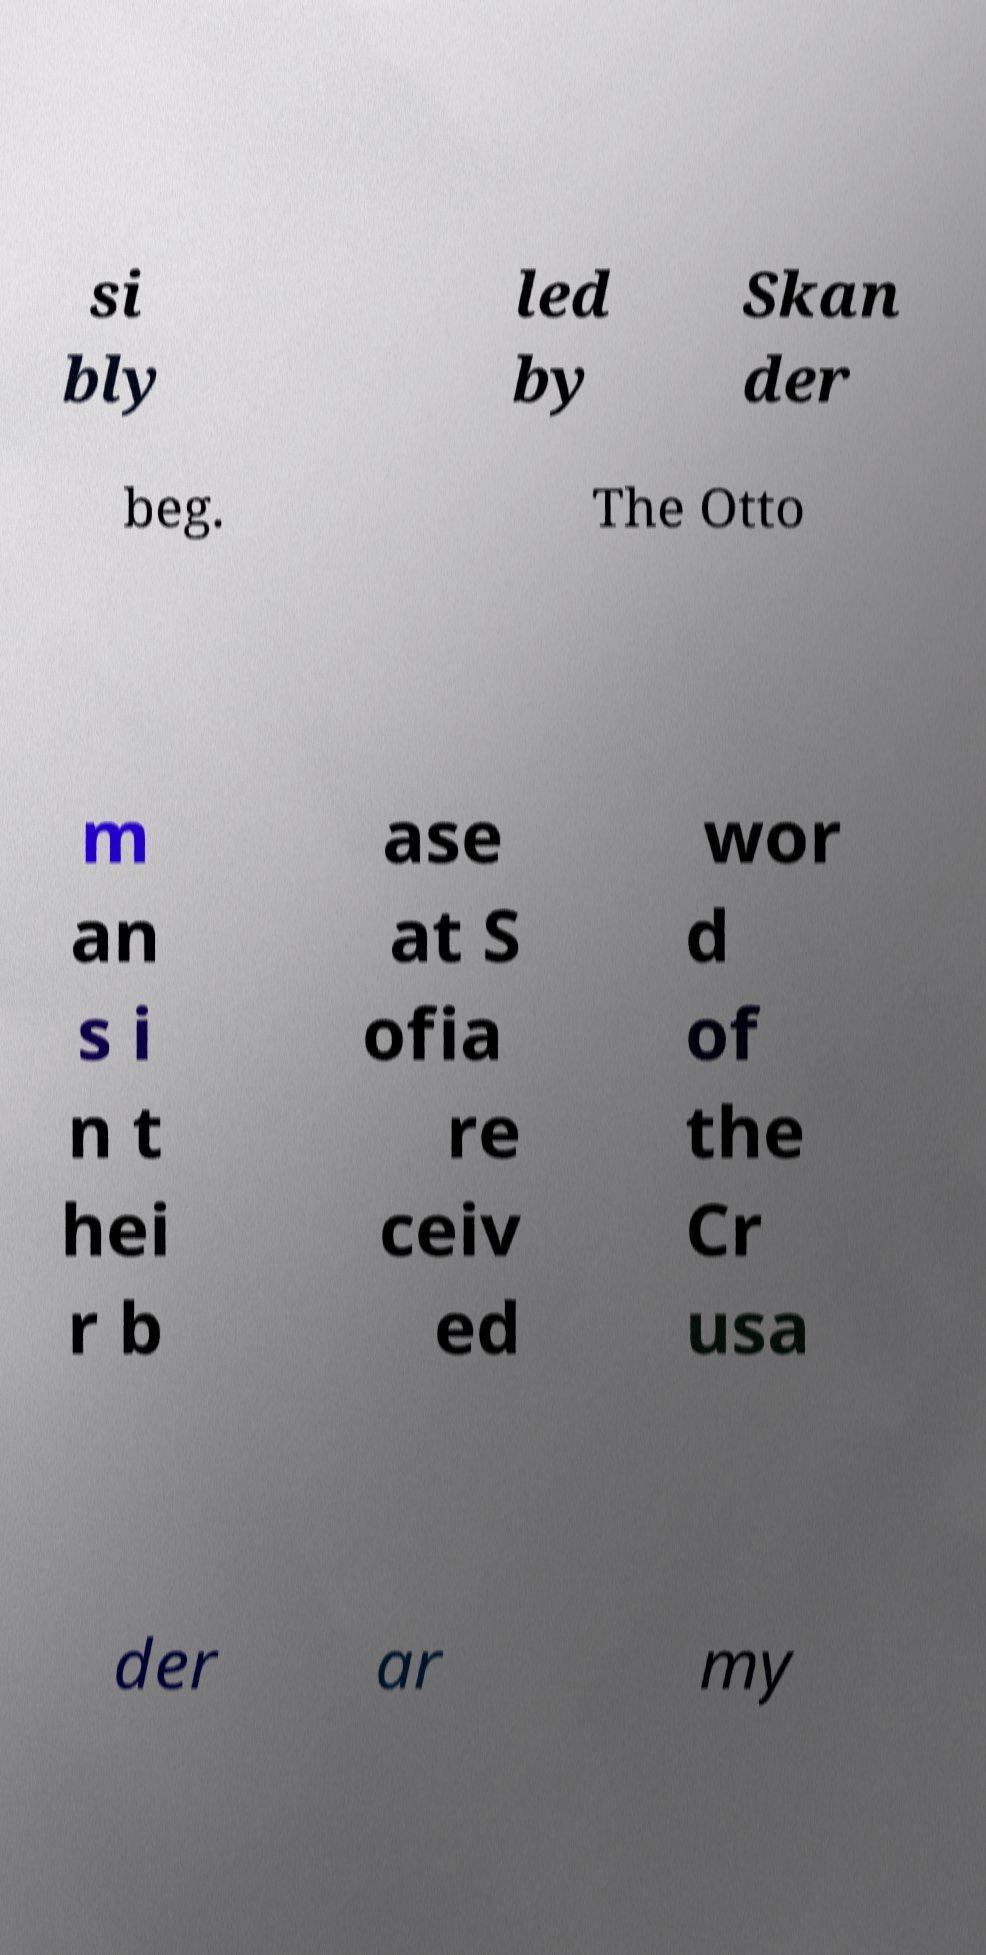I need the written content from this picture converted into text. Can you do that? si bly led by Skan der beg. The Otto m an s i n t hei r b ase at S ofia re ceiv ed wor d of the Cr usa der ar my 